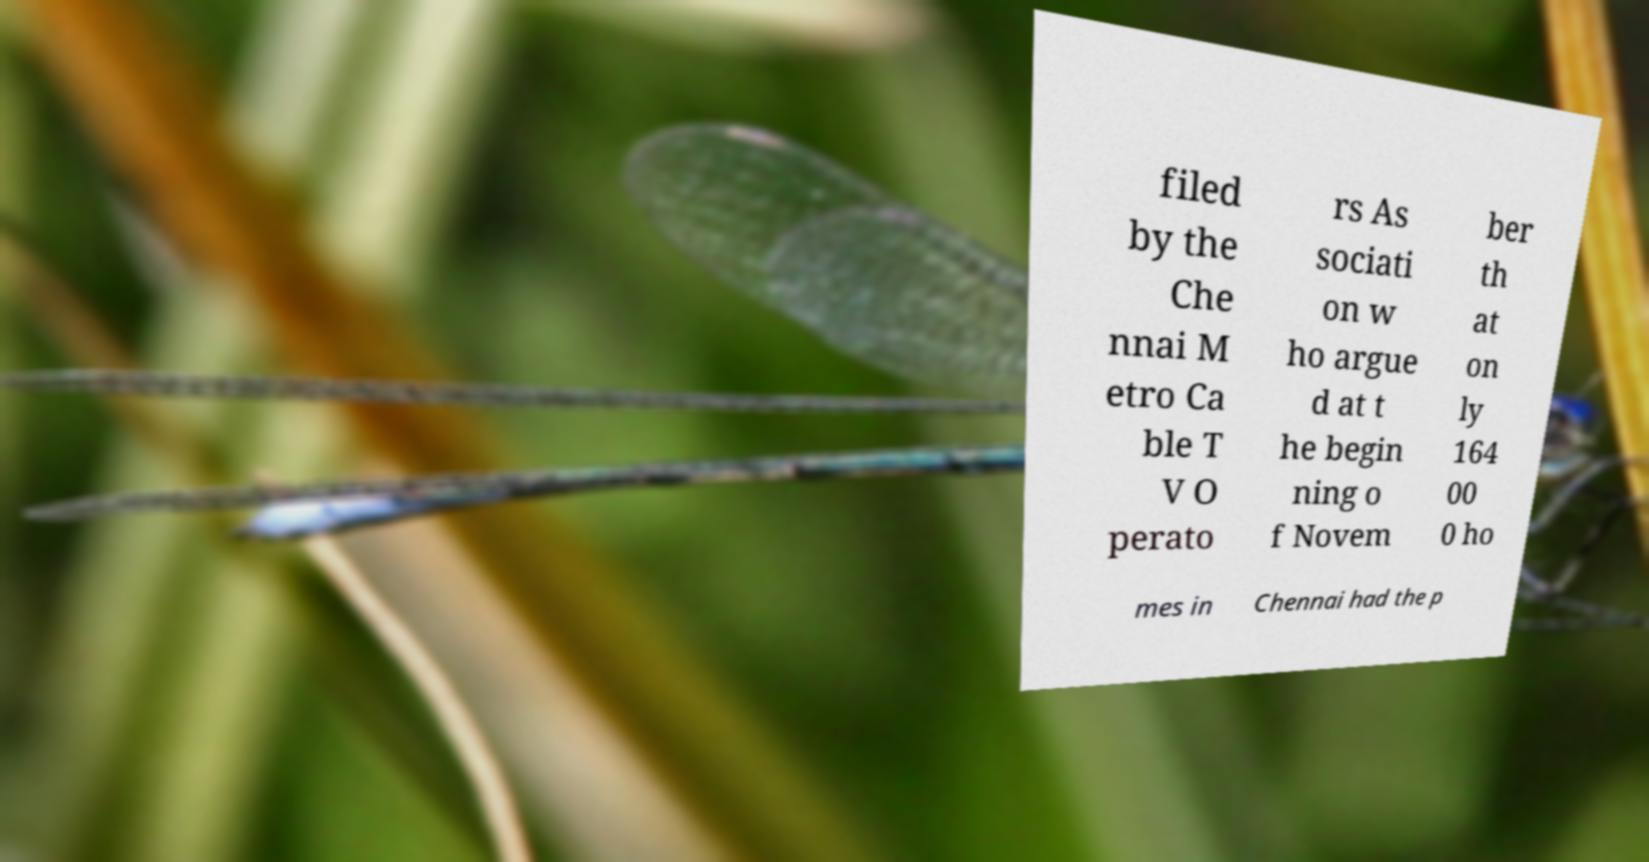Could you extract and type out the text from this image? filed by the Che nnai M etro Ca ble T V O perato rs As sociati on w ho argue d at t he begin ning o f Novem ber th at on ly 164 00 0 ho mes in Chennai had the p 